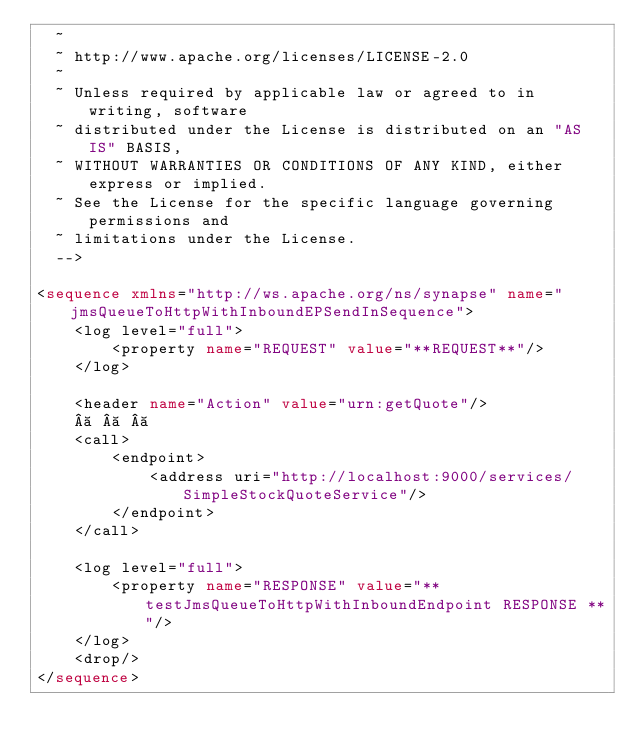<code> <loc_0><loc_0><loc_500><loc_500><_XML_>  ~
  ~ http://www.apache.org/licenses/LICENSE-2.0
  ~
  ~ Unless required by applicable law or agreed to in writing, software
  ~ distributed under the License is distributed on an "AS IS" BASIS,
  ~ WITHOUT WARRANTIES OR CONDITIONS OF ANY KIND, either express or implied.
  ~ See the License for the specific language governing permissions and
  ~ limitations under the License.
  -->

<sequence xmlns="http://ws.apache.org/ns/synapse" name="jmsQueueToHttpWithInboundEPSendInSequence">
    <log level="full">
        <property name="REQUEST" value="**REQUEST**"/>
    </log>

    <header name="Action" value="urn:getQuote"/>
         
    <call>
        <endpoint>
            <address uri="http://localhost:9000/services/SimpleStockQuoteService"/>
        </endpoint>
    </call>

    <log level="full">
        <property name="RESPONSE" value="** testJmsQueueToHttpWithInboundEndpoint RESPONSE **"/>
    </log>
    <drop/>
</sequence>
</code> 